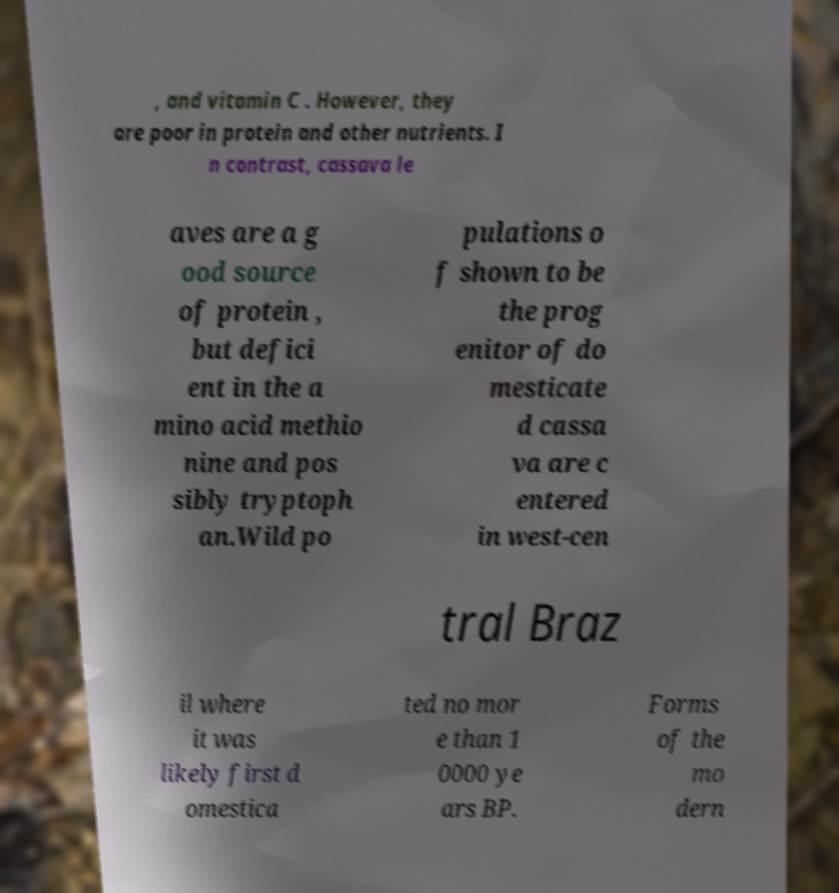Can you accurately transcribe the text from the provided image for me? , and vitamin C . However, they are poor in protein and other nutrients. I n contrast, cassava le aves are a g ood source of protein , but defici ent in the a mino acid methio nine and pos sibly tryptoph an.Wild po pulations o f shown to be the prog enitor of do mesticate d cassa va are c entered in west-cen tral Braz il where it was likely first d omestica ted no mor e than 1 0000 ye ars BP. Forms of the mo dern 